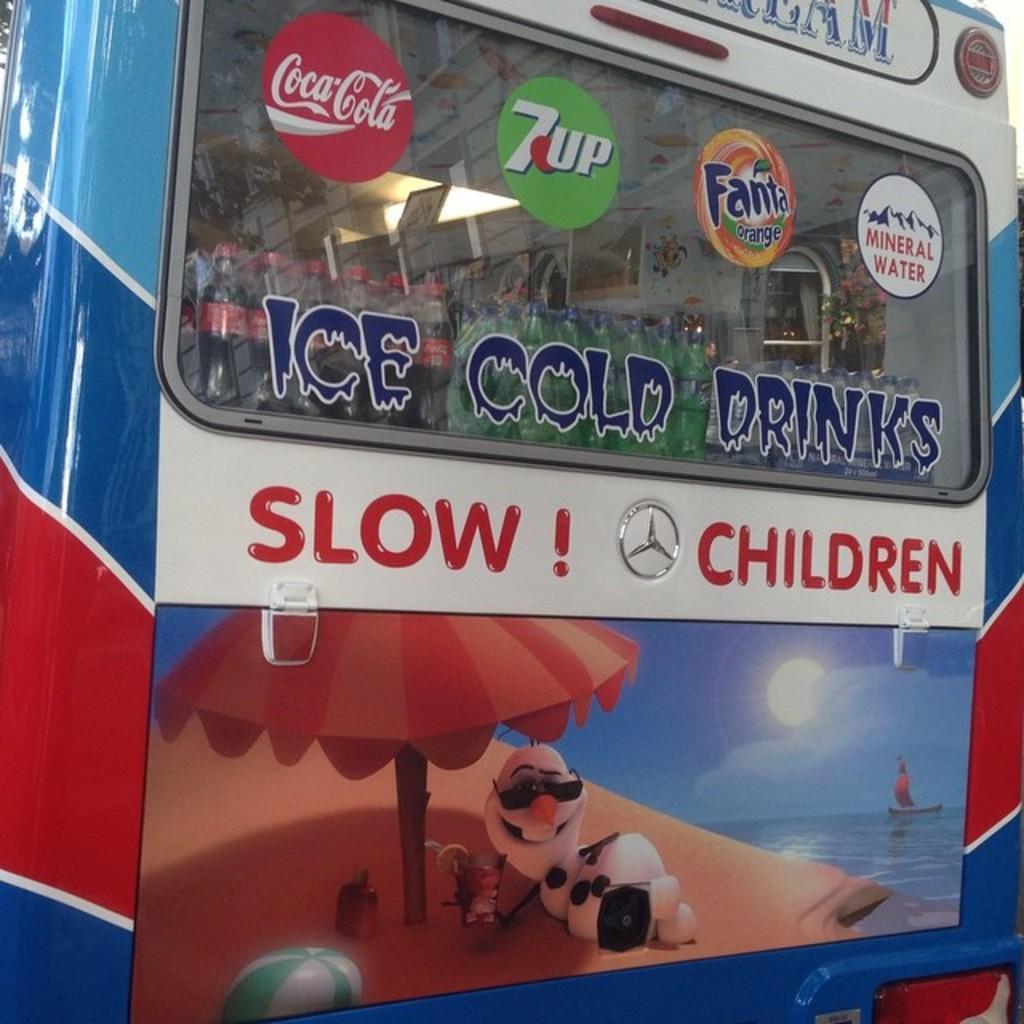Could you give a brief overview of what you see in this image? In this image there is a van with a text and a few paintings on it. 